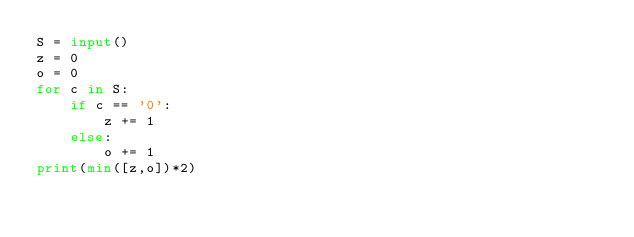<code> <loc_0><loc_0><loc_500><loc_500><_Python_>S = input()
z = 0
o = 0
for c in S:
    if c == '0':
        z += 1
    else:
        o += 1
print(min([z,o])*2)</code> 